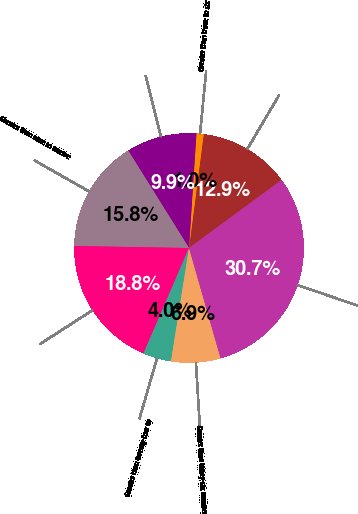Convert chart. <chart><loc_0><loc_0><loc_500><loc_500><pie_chart><fcel>Three months or less<fcel>Greater than three to six<fcel>Greater than six to nine<fcel>Greater than nine to twelve<fcel>Greater than twelve to<fcel>Greater than twenty-four to<fcel>Greater than thirty-six months<fcel>Total fixed maturity<nl><fcel>12.87%<fcel>1.01%<fcel>9.91%<fcel>15.84%<fcel>18.8%<fcel>3.98%<fcel>6.94%<fcel>30.66%<nl></chart> 